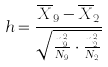<formula> <loc_0><loc_0><loc_500><loc_500>h = \frac { \overline { X } _ { 9 } - \overline { X } _ { 2 } } { \sqrt { \frac { n _ { 9 } ^ { 2 } } { N _ { 9 } } \cdot \frac { n _ { 2 } ^ { 2 } } { N _ { 2 } } } }</formula> 